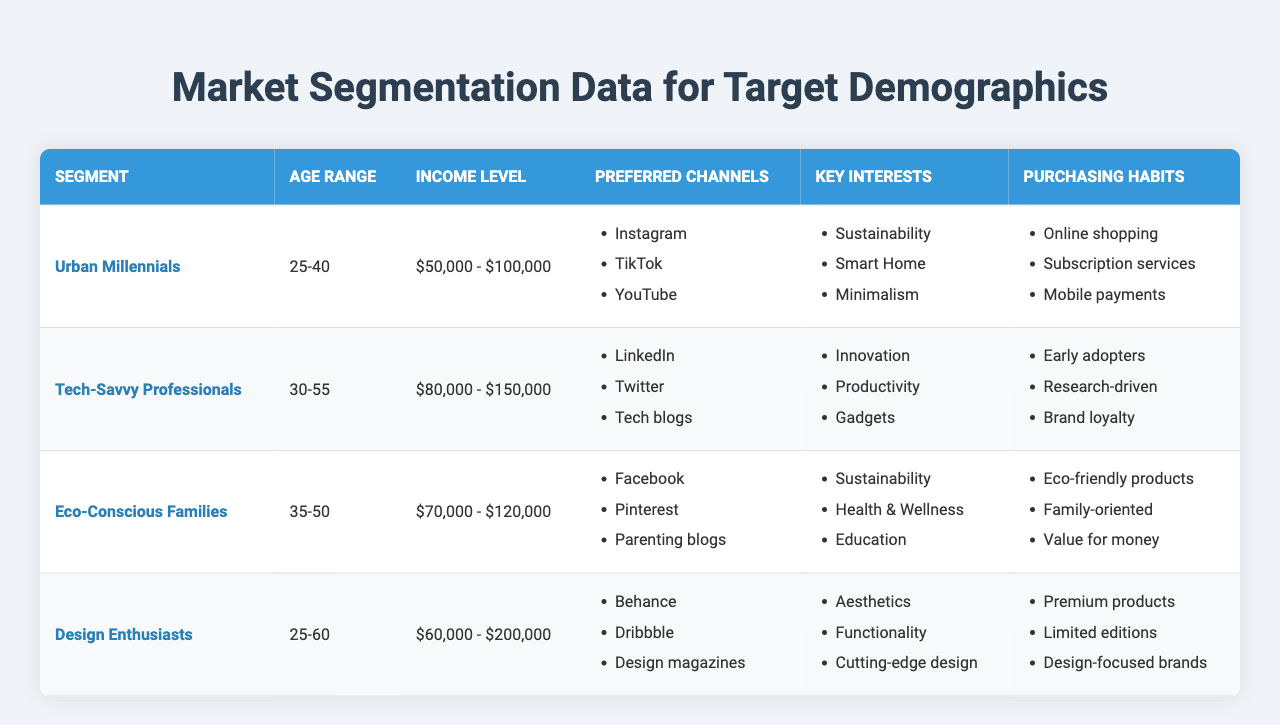What is the income level of the "Urban Millennials" segment? The table shows that the income level for the "Urban Millennials" segment is listed as "$50,000 - $100,000". This is found directly in the corresponding row for this segment.
Answer: $50,000 - $100,000 Which segment has the highest income level? The income levels for each segment are "$50,000 - $100,000" for Urban Millennials, "$80,000 - $150,000" for Tech-Savvy Professionals, "$70,000 - $120,000" for Eco-Conscious Families, and "$60,000 - $200,000" for Design Enthusiasts. Among these, the Design Enthusiasts segment, with a range of "$60,000 - $200,000", has the highest potential income level.
Answer: Design Enthusiasts Are "Instagram" and "Tech blogs" both preferred channels for any segment? The preferred channels for Urban Millennials include "Instagram" and for Tech-Savvy Professionals, it includes "Tech blogs". Since no segment lists both channels, the answer is no.
Answer: No Which purchasing habit is commonly shared between Eco-Conscious Families and Urban Millennials? The purchasing habit of valuing "Eco-friendly products" is reflected in Eco-Conscious Families, while Urban Millennials have a focus on "Sustainability". Although both segments are inclined towards sustainability, Urban Millennials don't explicitly list "Eco-friendly products", thus indicating they might not share this purchasing habit directly. The similarity lies more in the conceptual interest rather than a shared listing.
Answer: No shared purchasing habit What is the average age range of the segments listed? The age ranges provided are "25-40", "30-55", "35-50", and "25-60", which are transformed into numerical values for calculation: (32.5, 42.5, 42.5, 42.5) because each range is taken as the midpoint for simplicity. The average can then be calculated as (32.5 + 42.5 + 42.5 + 42.5) / 4 = 39.25.
Answer: 39.25 Which segment has the key interest of "Health & Wellness"? The table indicates that "Health & Wellness" is listed as a key interest specifically for "Eco-Conscious Families". This is found directly in that segment's row under key interests.
Answer: Eco-Conscious Families What is the relationship between the preferred channels and purchasing habits of Tech-Savvy Professionals? The preferred channels include "LinkedIn", "Twitter", and "Tech blogs", which focus on connecting with others and staying informed. Their purchasing habits as "Early adopters", "Research-driven", and "Brand loyalty" suggest that they would likely research products thoroughly through these channels before making purchases. Thus, these channels align well with their purchasing habits based on their professional interests.
Answer: They align well Which segment has a focus on "Aesthetics" as a key interest? The focus on "Aesthetics" is explicitly listed as a key interest in the "Design Enthusiasts" segment. This can be directly referenced from the segment’s respective row in the table.
Answer: Design Enthusiasts Identify the segments that utilize "Facebook" as a preferred channel. According to the table, "Facebook" is indicated as a preferred channel by the "Eco-Conscious Families" segment. The reference to the desired communication channel can be found in the respective row dedicated to this segment.
Answer: Eco-Conscious Families 